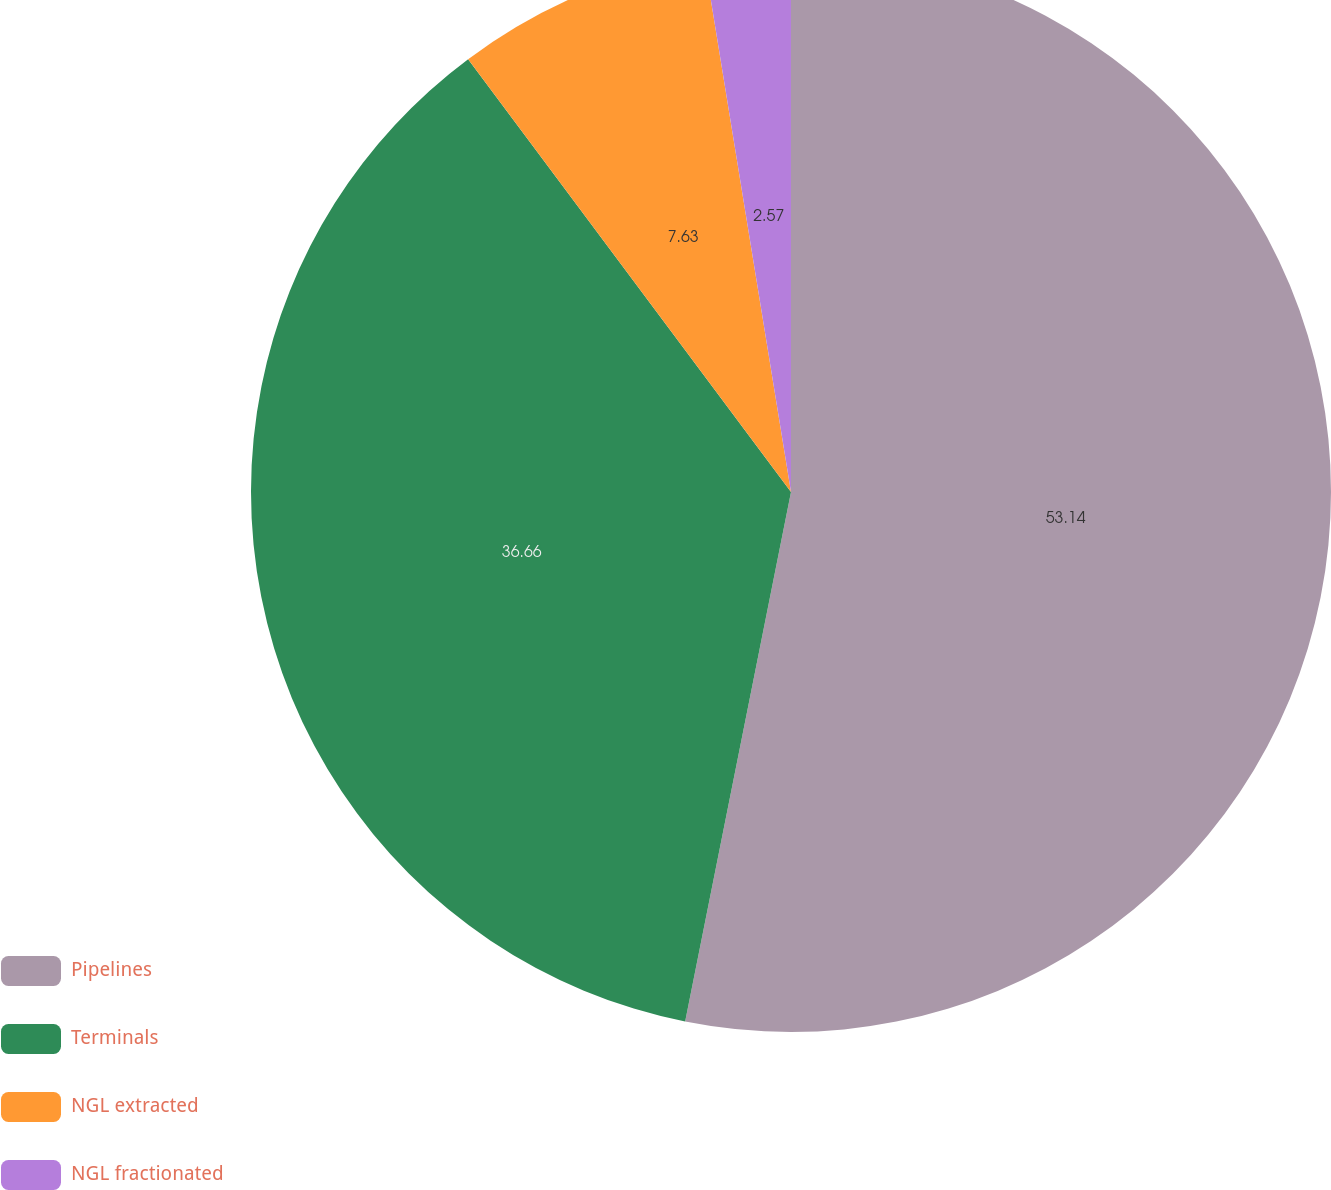<chart> <loc_0><loc_0><loc_500><loc_500><pie_chart><fcel>Pipelines<fcel>Terminals<fcel>NGL extracted<fcel>NGL fractionated<nl><fcel>53.14%<fcel>36.66%<fcel>7.63%<fcel>2.57%<nl></chart> 